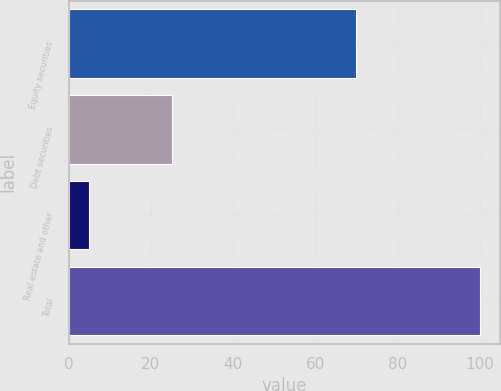<chart> <loc_0><loc_0><loc_500><loc_500><bar_chart><fcel>Equity securities<fcel>Debt securities<fcel>Real estate and other<fcel>Total<nl><fcel>70<fcel>25<fcel>5<fcel>100<nl></chart> 